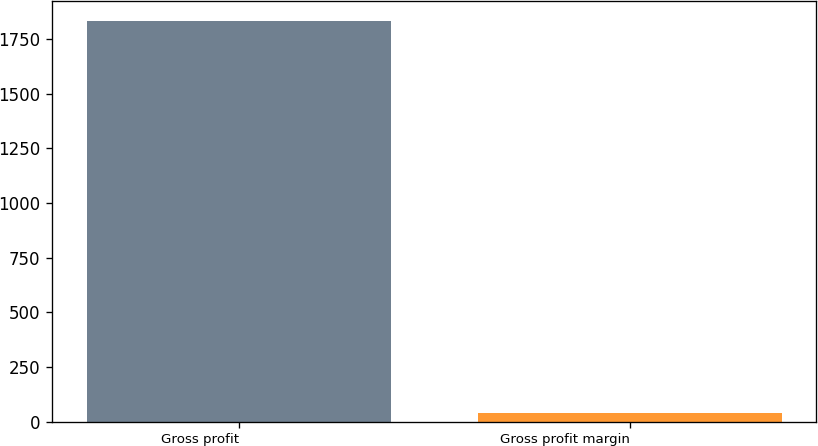Convert chart to OTSL. <chart><loc_0><loc_0><loc_500><loc_500><bar_chart><fcel>Gross profit<fcel>Gross profit margin<nl><fcel>1831.7<fcel>41.5<nl></chart> 